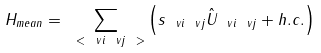<formula> <loc_0><loc_0><loc_500><loc_500>H _ { m e a n } = \sum _ { \ < \ v i \ v j \ > } \left ( s _ { \ v i \ v j } \hat { U } _ { \ v i \ v j } + h . c . \right )</formula> 